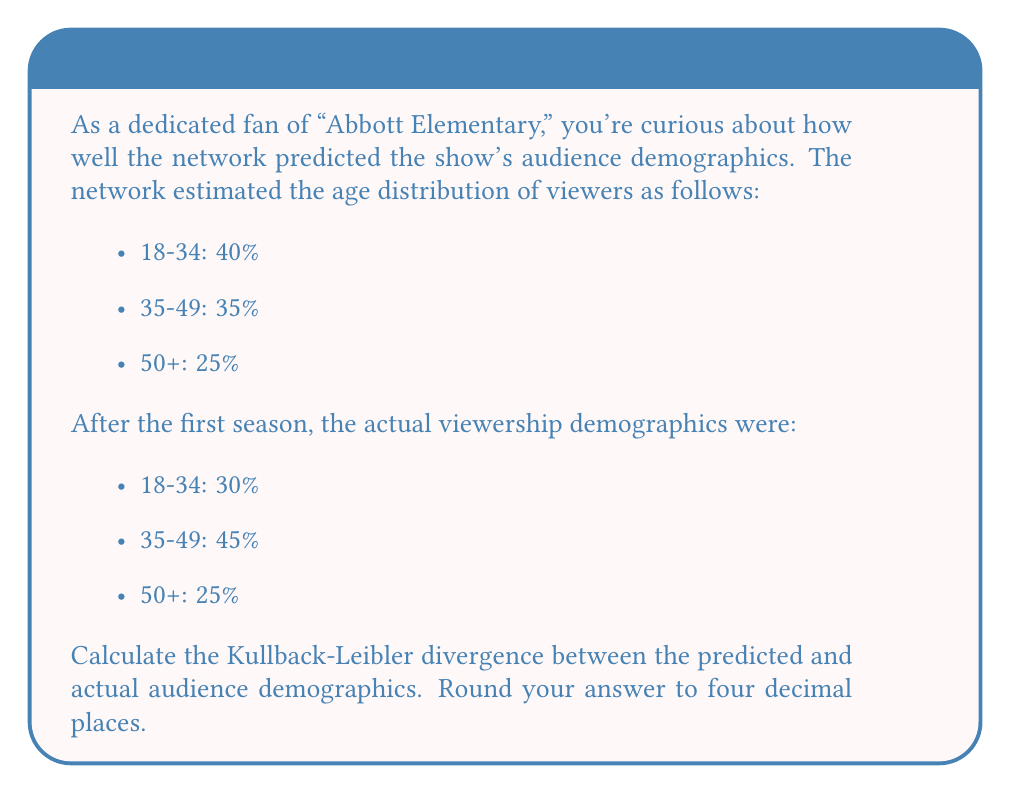Can you solve this math problem? To calculate the Kullback-Leibler (KL) divergence between the predicted (P) and actual (Q) audience demographics, we'll use the formula:

$$ D_{KL}(P||Q) = \sum_{i} P(i) \log\left(\frac{P(i)}{Q(i)}\right) $$

Where:
P(i) is the predicted probability for category i
Q(i) is the actual probability for category i

Step 1: Set up the calculation for each age group:

18-34: $0.40 \log\left(\frac{0.40}{0.30}\right)$
35-49: $0.35 \log\left(\frac{0.35}{0.45}\right)$
50+: $0.25 \log\left(\frac{0.25}{0.25}\right)$

Step 2: Calculate each term:

18-34: $0.40 \log(1.3333) = 0.40 \times 0.2877 = 0.1151$
35-49: $0.35 \log(0.7778) = 0.35 \times (-0.2513) = -0.0880$
50+: $0.25 \log(1) = 0 \times 0.25 = 0$

Step 3: Sum the results:

$D_{KL}(P||Q) = 0.1151 + (-0.0880) + 0 = 0.0271$

Step 4: Round to four decimal places:

$D_{KL}(P||Q) = 0.0271$
Answer: 0.0271 